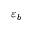<formula> <loc_0><loc_0><loc_500><loc_500>\varepsilon _ { b }</formula> 